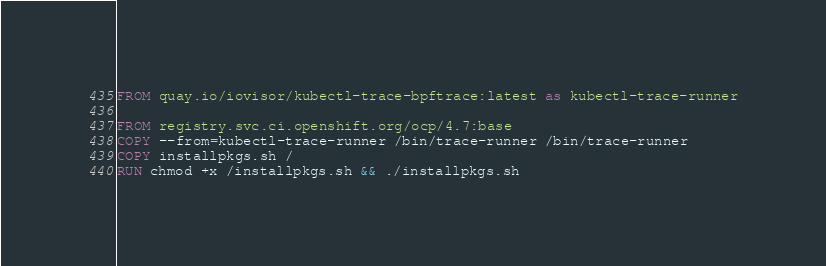<code> <loc_0><loc_0><loc_500><loc_500><_Dockerfile_>FROM quay.io/iovisor/kubectl-trace-bpftrace:latest as kubectl-trace-runner

FROM registry.svc.ci.openshift.org/ocp/4.7:base
COPY --from=kubectl-trace-runner /bin/trace-runner /bin/trace-runner
COPY installpkgs.sh /
RUN chmod +x /installpkgs.sh && ./installpkgs.sh

</code> 